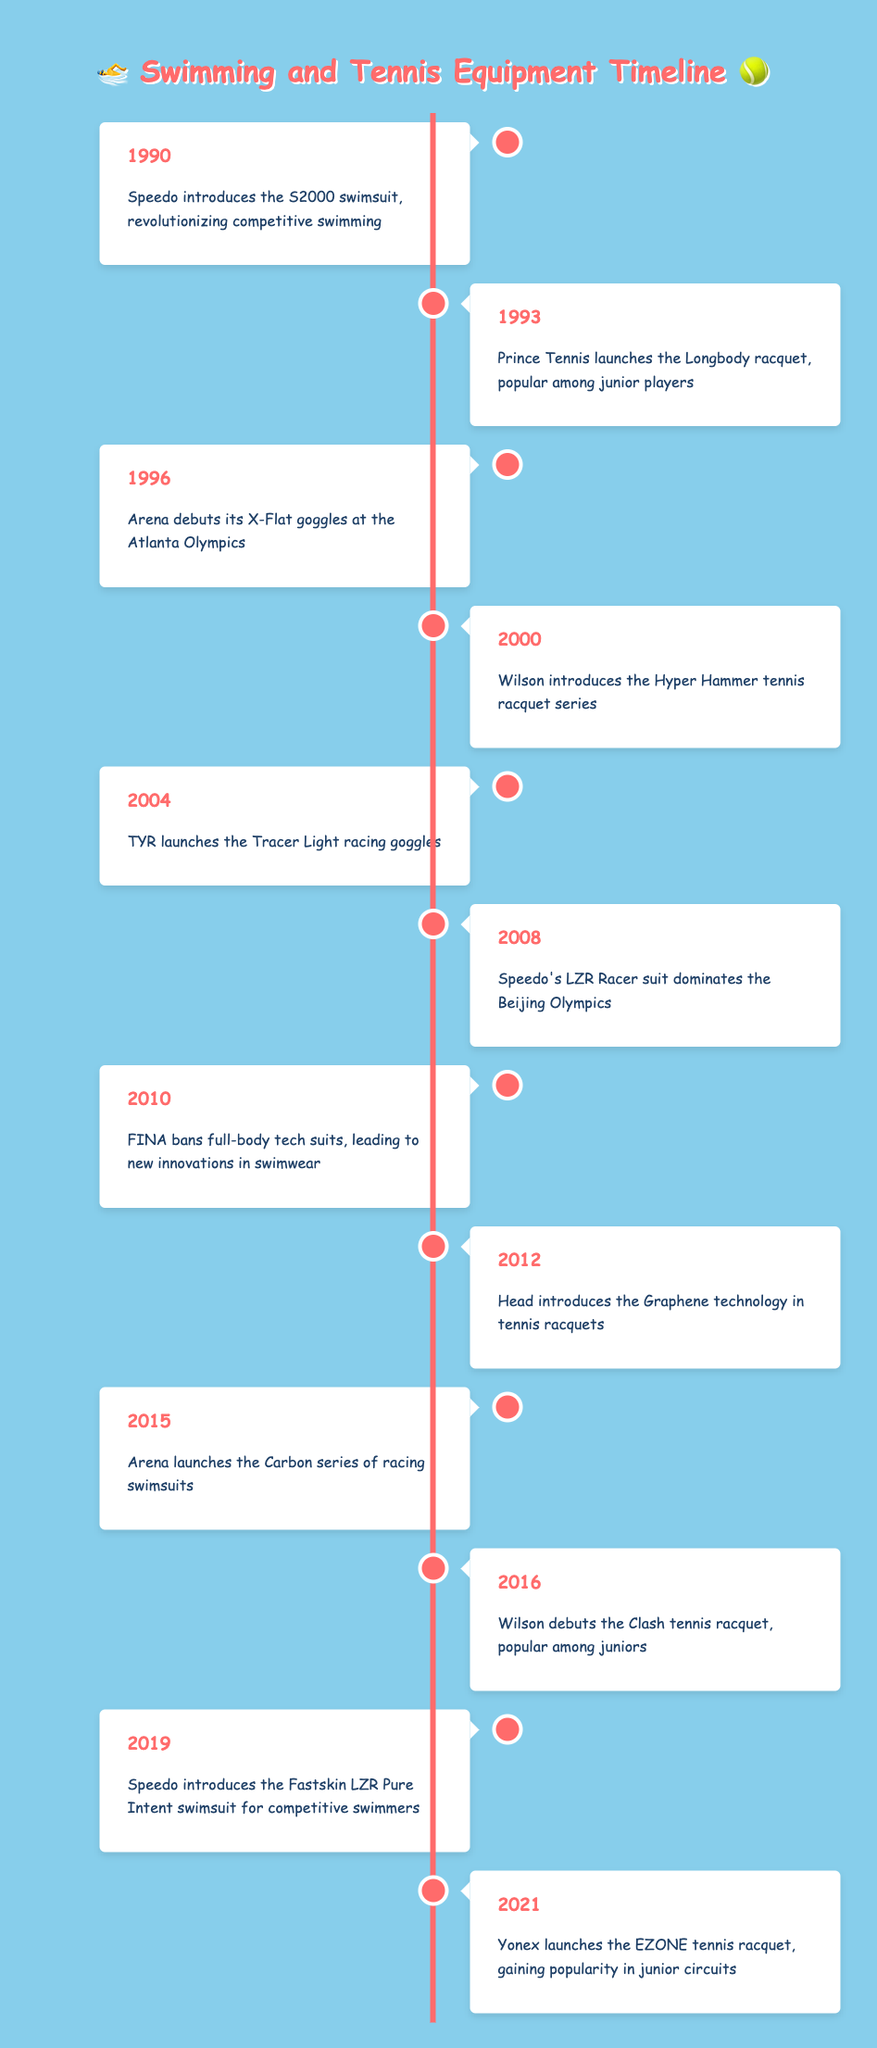What event did Speedo introduce in 1990? According to the table, in 1990, Speedo introduced the S2000 swimsuit, which is highlighted as a significant advancement in competitive swimming.
Answer: Speedo introduces the S2000 swimsuit Which tennis brand launched a popular racquet in 1993? The table indicates that in 1993, Prince Tennis launched the Longbody racquet, specifically noted for its popularity among junior players.
Answer: Prince Tennis What year did TYR launch the Tracer Light racing goggles? The table specifies that TYR launched the Tracer Light racing goggles in the year 2004.
Answer: 2004 How many years apart were the introductions of the Speedo Fastskin LZR Pure Intent and the Yonex EZONE racquet? The Speedo Fastskin LZR Pure Intent was introduced in 2019 and the Yonex EZONE was introduced in 2021. The difference in years is 2021 - 2019 = 2 years.
Answer: 2 years Did Wilson debut the Clash tennis racquet before or after 2016? According to the timeline, the Clash tennis racquet was debuted by Wilson in 2016, which means it was not before that year. Hence, the answer is after 2016.
Answer: No In what year was FINA's ban on full-body tech suits, leading to innovations in swimwear? The timeline states that FINA banned full-body tech suits in 2010, which prompted new innovations in swimwear.
Answer: 2010 Which brand introduced a racquet in 2012 that featured Graphene technology? According to the timeline data, Head introduced the tennis racquet with Graphene technology in 2012.
Answer: Head Which two events occurred around the turn of the millennium? Looking at the timeline, the events around the year 2000 include the introduction of Wilson's Hyper Hammer tennis racquet series (2000) and TYR's launch of Tracer Light racing goggles (2004).
Answer: Hyper Hammer and Tracer Light List all the brands mentioned in the timeline that introduced products between 2010 and 2021. From the data: In 2010, FINA's ban on tech suits led to innovations; in 2012, Head introduced Graphene technology; in 2015, Arena launched the Carbon series; in 2016, Wilson debuted the Clash racquet; in 2019, Speedo introduced the Fastskin LZR Pure Intent; and in 2021, Yonex launched the EZONE racquet. Thus, the brands are FINA, Head, Arena, Wilson, Speedo, and Yonex.
Answer: FINA, Head, Arena, Wilson, Speedo, Yonex 